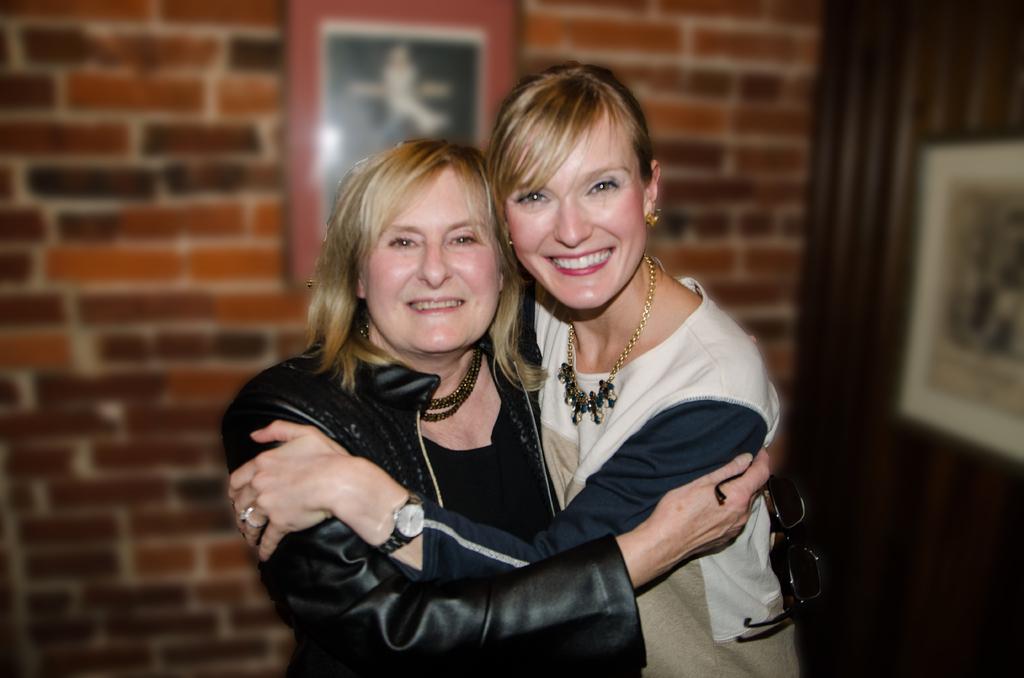In one or two sentences, can you explain what this image depicts? In this image in the foreground there are two women who are hugging each other, and in the background there are photo frames, wall and door. 